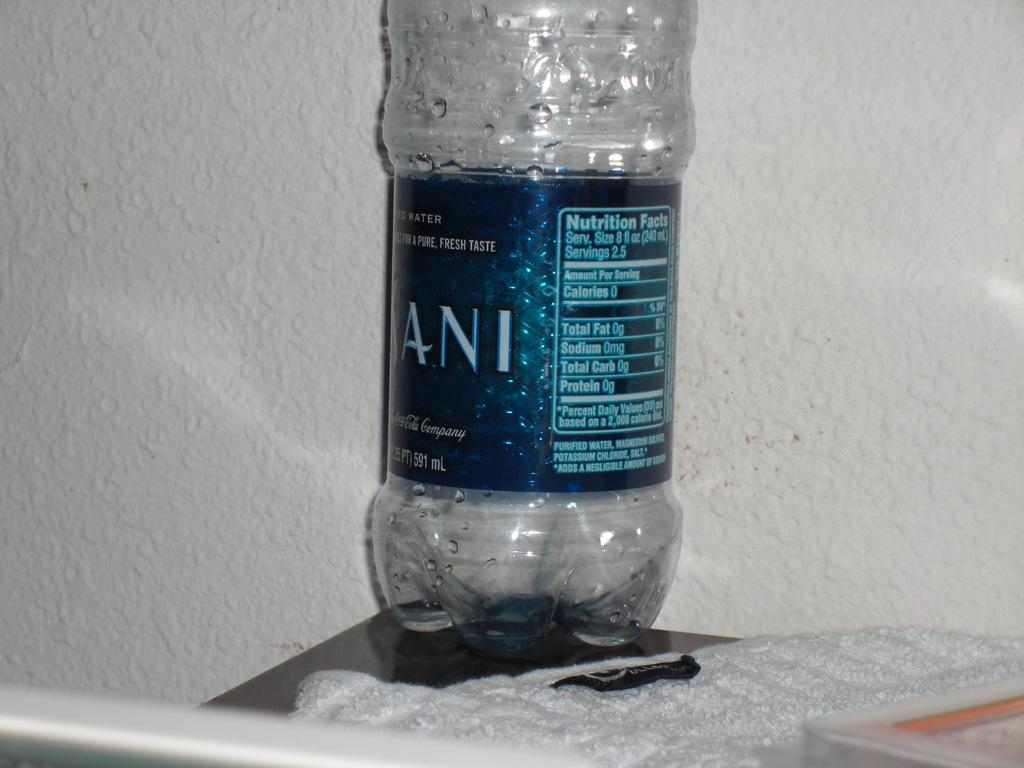Provide a one-sentence caption for the provided image. A Dasani water bottle sits on the corner of a dark table. 